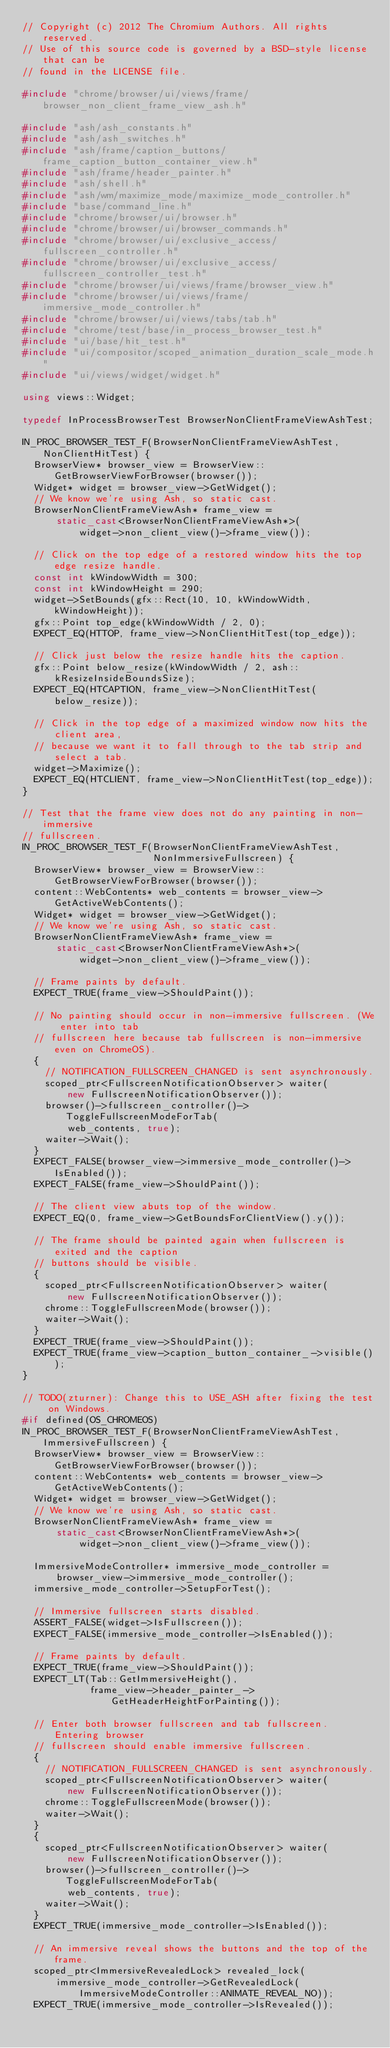Convert code to text. <code><loc_0><loc_0><loc_500><loc_500><_C++_>// Copyright (c) 2012 The Chromium Authors. All rights reserved.
// Use of this source code is governed by a BSD-style license that can be
// found in the LICENSE file.

#include "chrome/browser/ui/views/frame/browser_non_client_frame_view_ash.h"

#include "ash/ash_constants.h"
#include "ash/ash_switches.h"
#include "ash/frame/caption_buttons/frame_caption_button_container_view.h"
#include "ash/frame/header_painter.h"
#include "ash/shell.h"
#include "ash/wm/maximize_mode/maximize_mode_controller.h"
#include "base/command_line.h"
#include "chrome/browser/ui/browser.h"
#include "chrome/browser/ui/browser_commands.h"
#include "chrome/browser/ui/exclusive_access/fullscreen_controller.h"
#include "chrome/browser/ui/exclusive_access/fullscreen_controller_test.h"
#include "chrome/browser/ui/views/frame/browser_view.h"
#include "chrome/browser/ui/views/frame/immersive_mode_controller.h"
#include "chrome/browser/ui/views/tabs/tab.h"
#include "chrome/test/base/in_process_browser_test.h"
#include "ui/base/hit_test.h"
#include "ui/compositor/scoped_animation_duration_scale_mode.h"
#include "ui/views/widget/widget.h"

using views::Widget;

typedef InProcessBrowserTest BrowserNonClientFrameViewAshTest;

IN_PROC_BROWSER_TEST_F(BrowserNonClientFrameViewAshTest, NonClientHitTest) {
  BrowserView* browser_view = BrowserView::GetBrowserViewForBrowser(browser());
  Widget* widget = browser_view->GetWidget();
  // We know we're using Ash, so static cast.
  BrowserNonClientFrameViewAsh* frame_view =
      static_cast<BrowserNonClientFrameViewAsh*>(
          widget->non_client_view()->frame_view());

  // Click on the top edge of a restored window hits the top edge resize handle.
  const int kWindowWidth = 300;
  const int kWindowHeight = 290;
  widget->SetBounds(gfx::Rect(10, 10, kWindowWidth, kWindowHeight));
  gfx::Point top_edge(kWindowWidth / 2, 0);
  EXPECT_EQ(HTTOP, frame_view->NonClientHitTest(top_edge));

  // Click just below the resize handle hits the caption.
  gfx::Point below_resize(kWindowWidth / 2, ash::kResizeInsideBoundsSize);
  EXPECT_EQ(HTCAPTION, frame_view->NonClientHitTest(below_resize));

  // Click in the top edge of a maximized window now hits the client area,
  // because we want it to fall through to the tab strip and select a tab.
  widget->Maximize();
  EXPECT_EQ(HTCLIENT, frame_view->NonClientHitTest(top_edge));
}

// Test that the frame view does not do any painting in non-immersive
// fullscreen.
IN_PROC_BROWSER_TEST_F(BrowserNonClientFrameViewAshTest,
                       NonImmersiveFullscreen) {
  BrowserView* browser_view = BrowserView::GetBrowserViewForBrowser(browser());
  content::WebContents* web_contents = browser_view->GetActiveWebContents();
  Widget* widget = browser_view->GetWidget();
  // We know we're using Ash, so static cast.
  BrowserNonClientFrameViewAsh* frame_view =
      static_cast<BrowserNonClientFrameViewAsh*>(
          widget->non_client_view()->frame_view());

  // Frame paints by default.
  EXPECT_TRUE(frame_view->ShouldPaint());

  // No painting should occur in non-immersive fullscreen. (We enter into tab
  // fullscreen here because tab fullscreen is non-immersive even on ChromeOS).
  {
    // NOTIFICATION_FULLSCREEN_CHANGED is sent asynchronously.
    scoped_ptr<FullscreenNotificationObserver> waiter(
        new FullscreenNotificationObserver());
    browser()->fullscreen_controller()->ToggleFullscreenModeForTab(
        web_contents, true);
    waiter->Wait();
  }
  EXPECT_FALSE(browser_view->immersive_mode_controller()->IsEnabled());
  EXPECT_FALSE(frame_view->ShouldPaint());

  // The client view abuts top of the window.
  EXPECT_EQ(0, frame_view->GetBoundsForClientView().y());

  // The frame should be painted again when fullscreen is exited and the caption
  // buttons should be visible.
  {
    scoped_ptr<FullscreenNotificationObserver> waiter(
        new FullscreenNotificationObserver());
    chrome::ToggleFullscreenMode(browser());
    waiter->Wait();
  }
  EXPECT_TRUE(frame_view->ShouldPaint());
  EXPECT_TRUE(frame_view->caption_button_container_->visible());
}

// TODO(zturner): Change this to USE_ASH after fixing the test on Windows.
#if defined(OS_CHROMEOS)
IN_PROC_BROWSER_TEST_F(BrowserNonClientFrameViewAshTest, ImmersiveFullscreen) {
  BrowserView* browser_view = BrowserView::GetBrowserViewForBrowser(browser());
  content::WebContents* web_contents = browser_view->GetActiveWebContents();
  Widget* widget = browser_view->GetWidget();
  // We know we're using Ash, so static cast.
  BrowserNonClientFrameViewAsh* frame_view =
      static_cast<BrowserNonClientFrameViewAsh*>(
          widget->non_client_view()->frame_view());

  ImmersiveModeController* immersive_mode_controller =
      browser_view->immersive_mode_controller();
  immersive_mode_controller->SetupForTest();

  // Immersive fullscreen starts disabled.
  ASSERT_FALSE(widget->IsFullscreen());
  EXPECT_FALSE(immersive_mode_controller->IsEnabled());

  // Frame paints by default.
  EXPECT_TRUE(frame_view->ShouldPaint());
  EXPECT_LT(Tab::GetImmersiveHeight(),
            frame_view->header_painter_->GetHeaderHeightForPainting());

  // Enter both browser fullscreen and tab fullscreen. Entering browser
  // fullscreen should enable immersive fullscreen.
  {
    // NOTIFICATION_FULLSCREEN_CHANGED is sent asynchronously.
    scoped_ptr<FullscreenNotificationObserver> waiter(
        new FullscreenNotificationObserver());
    chrome::ToggleFullscreenMode(browser());
    waiter->Wait();
  }
  {
    scoped_ptr<FullscreenNotificationObserver> waiter(
        new FullscreenNotificationObserver());
    browser()->fullscreen_controller()->ToggleFullscreenModeForTab(
        web_contents, true);
    waiter->Wait();
  }
  EXPECT_TRUE(immersive_mode_controller->IsEnabled());

  // An immersive reveal shows the buttons and the top of the frame.
  scoped_ptr<ImmersiveRevealedLock> revealed_lock(
      immersive_mode_controller->GetRevealedLock(
          ImmersiveModeController::ANIMATE_REVEAL_NO));
  EXPECT_TRUE(immersive_mode_controller->IsRevealed());</code> 